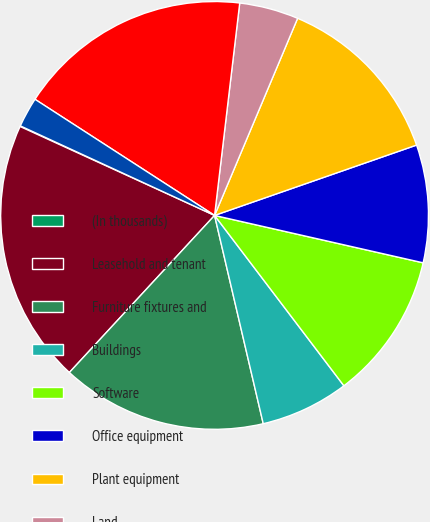<chart> <loc_0><loc_0><loc_500><loc_500><pie_chart><fcel>(In thousands)<fcel>Leasehold and tenant<fcel>Furniture fixtures and<fcel>Buildings<fcel>Software<fcel>Office equipment<fcel>Plant equipment<fcel>Land<fcel>Construction in progress<fcel>Other<nl><fcel>0.05%<fcel>19.95%<fcel>15.53%<fcel>6.68%<fcel>11.11%<fcel>8.89%<fcel>13.32%<fcel>4.47%<fcel>17.74%<fcel>2.26%<nl></chart> 